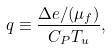<formula> <loc_0><loc_0><loc_500><loc_500>q \equiv \frac { \Delta e / ( \mu _ { f } ) } { C _ { P } T _ { u } } ,</formula> 